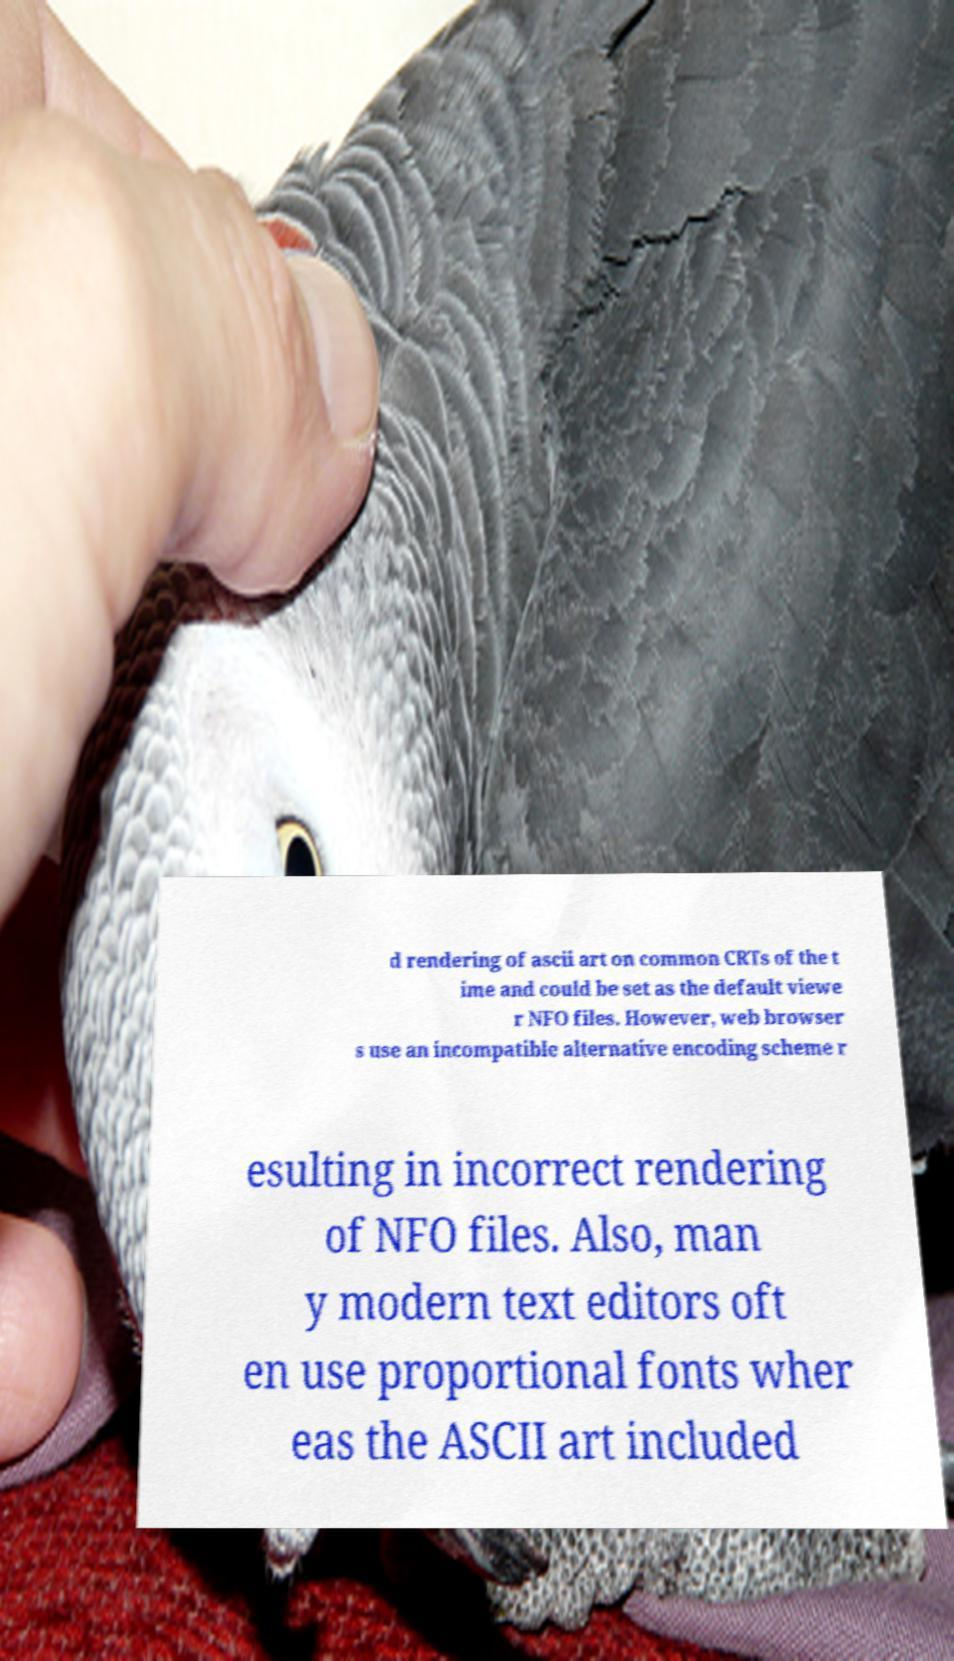For documentation purposes, I need the text within this image transcribed. Could you provide that? d rendering of ascii art on common CRTs of the t ime and could be set as the default viewe r NFO files. However, web browser s use an incompatible alternative encoding scheme r esulting in incorrect rendering of NFO files. Also, man y modern text editors oft en use proportional fonts wher eas the ASCII art included 